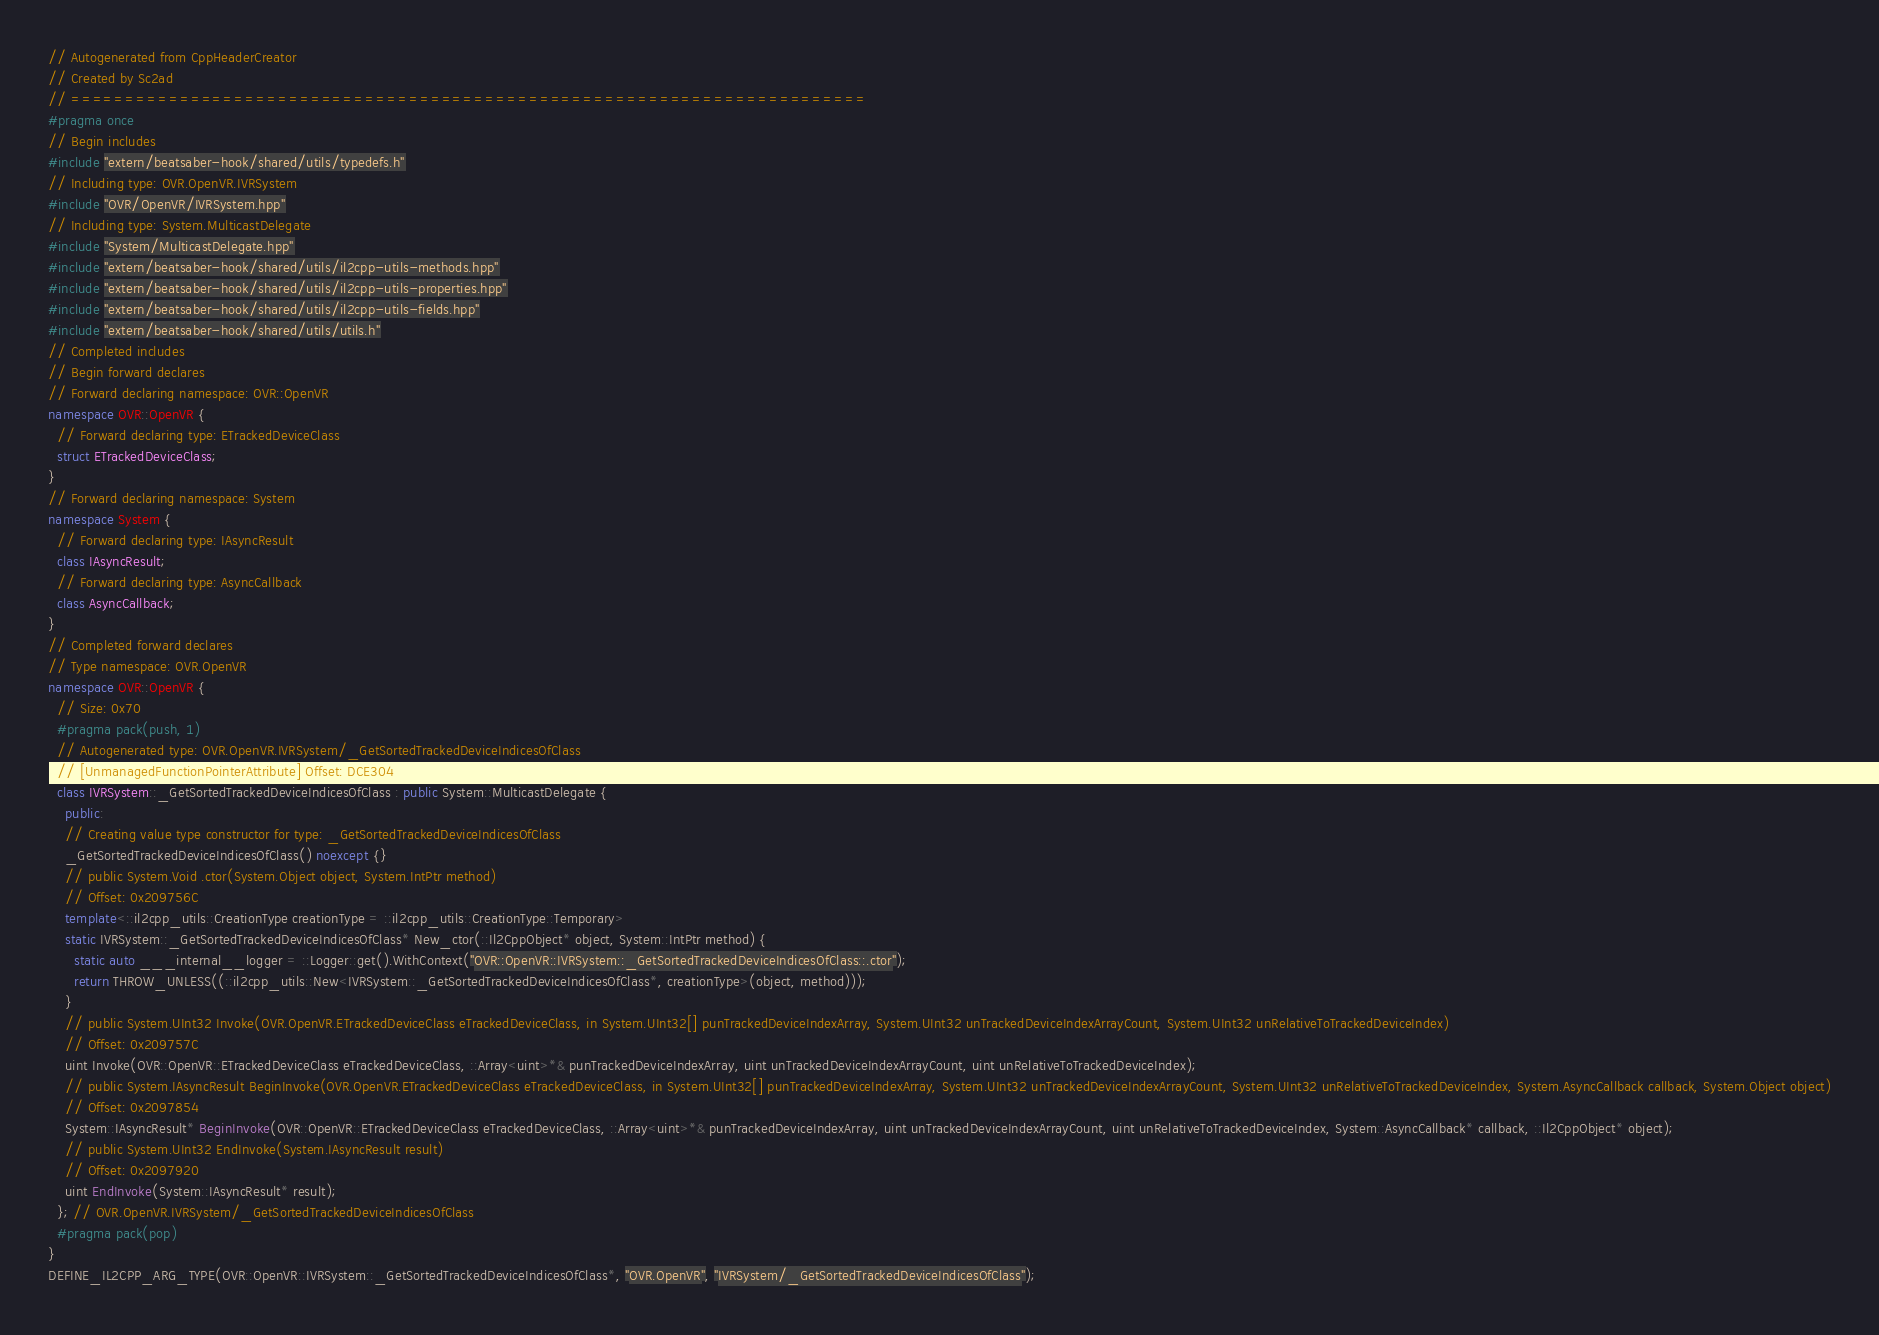Convert code to text. <code><loc_0><loc_0><loc_500><loc_500><_C++_>// Autogenerated from CppHeaderCreator
// Created by Sc2ad
// =========================================================================
#pragma once
// Begin includes
#include "extern/beatsaber-hook/shared/utils/typedefs.h"
// Including type: OVR.OpenVR.IVRSystem
#include "OVR/OpenVR/IVRSystem.hpp"
// Including type: System.MulticastDelegate
#include "System/MulticastDelegate.hpp"
#include "extern/beatsaber-hook/shared/utils/il2cpp-utils-methods.hpp"
#include "extern/beatsaber-hook/shared/utils/il2cpp-utils-properties.hpp"
#include "extern/beatsaber-hook/shared/utils/il2cpp-utils-fields.hpp"
#include "extern/beatsaber-hook/shared/utils/utils.h"
// Completed includes
// Begin forward declares
// Forward declaring namespace: OVR::OpenVR
namespace OVR::OpenVR {
  // Forward declaring type: ETrackedDeviceClass
  struct ETrackedDeviceClass;
}
// Forward declaring namespace: System
namespace System {
  // Forward declaring type: IAsyncResult
  class IAsyncResult;
  // Forward declaring type: AsyncCallback
  class AsyncCallback;
}
// Completed forward declares
// Type namespace: OVR.OpenVR
namespace OVR::OpenVR {
  // Size: 0x70
  #pragma pack(push, 1)
  // Autogenerated type: OVR.OpenVR.IVRSystem/_GetSortedTrackedDeviceIndicesOfClass
  // [UnmanagedFunctionPointerAttribute] Offset: DCE304
  class IVRSystem::_GetSortedTrackedDeviceIndicesOfClass : public System::MulticastDelegate {
    public:
    // Creating value type constructor for type: _GetSortedTrackedDeviceIndicesOfClass
    _GetSortedTrackedDeviceIndicesOfClass() noexcept {}
    // public System.Void .ctor(System.Object object, System.IntPtr method)
    // Offset: 0x209756C
    template<::il2cpp_utils::CreationType creationType = ::il2cpp_utils::CreationType::Temporary>
    static IVRSystem::_GetSortedTrackedDeviceIndicesOfClass* New_ctor(::Il2CppObject* object, System::IntPtr method) {
      static auto ___internal__logger = ::Logger::get().WithContext("OVR::OpenVR::IVRSystem::_GetSortedTrackedDeviceIndicesOfClass::.ctor");
      return THROW_UNLESS((::il2cpp_utils::New<IVRSystem::_GetSortedTrackedDeviceIndicesOfClass*, creationType>(object, method)));
    }
    // public System.UInt32 Invoke(OVR.OpenVR.ETrackedDeviceClass eTrackedDeviceClass, in System.UInt32[] punTrackedDeviceIndexArray, System.UInt32 unTrackedDeviceIndexArrayCount, System.UInt32 unRelativeToTrackedDeviceIndex)
    // Offset: 0x209757C
    uint Invoke(OVR::OpenVR::ETrackedDeviceClass eTrackedDeviceClass, ::Array<uint>*& punTrackedDeviceIndexArray, uint unTrackedDeviceIndexArrayCount, uint unRelativeToTrackedDeviceIndex);
    // public System.IAsyncResult BeginInvoke(OVR.OpenVR.ETrackedDeviceClass eTrackedDeviceClass, in System.UInt32[] punTrackedDeviceIndexArray, System.UInt32 unTrackedDeviceIndexArrayCount, System.UInt32 unRelativeToTrackedDeviceIndex, System.AsyncCallback callback, System.Object object)
    // Offset: 0x2097854
    System::IAsyncResult* BeginInvoke(OVR::OpenVR::ETrackedDeviceClass eTrackedDeviceClass, ::Array<uint>*& punTrackedDeviceIndexArray, uint unTrackedDeviceIndexArrayCount, uint unRelativeToTrackedDeviceIndex, System::AsyncCallback* callback, ::Il2CppObject* object);
    // public System.UInt32 EndInvoke(System.IAsyncResult result)
    // Offset: 0x2097920
    uint EndInvoke(System::IAsyncResult* result);
  }; // OVR.OpenVR.IVRSystem/_GetSortedTrackedDeviceIndicesOfClass
  #pragma pack(pop)
}
DEFINE_IL2CPP_ARG_TYPE(OVR::OpenVR::IVRSystem::_GetSortedTrackedDeviceIndicesOfClass*, "OVR.OpenVR", "IVRSystem/_GetSortedTrackedDeviceIndicesOfClass");
</code> 